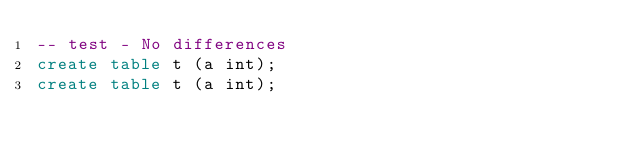<code> <loc_0><loc_0><loc_500><loc_500><_SQL_>-- test - No differences
create table t (a int);
create table t (a int);

</code> 